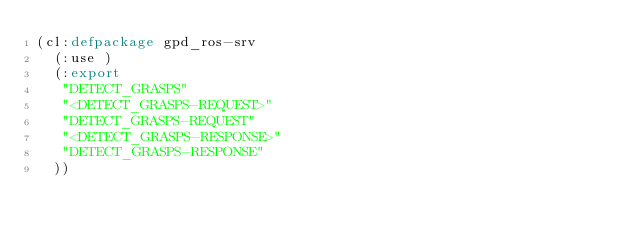Convert code to text. <code><loc_0><loc_0><loc_500><loc_500><_Lisp_>(cl:defpackage gpd_ros-srv
  (:use )
  (:export
   "DETECT_GRASPS"
   "<DETECT_GRASPS-REQUEST>"
   "DETECT_GRASPS-REQUEST"
   "<DETECT_GRASPS-RESPONSE>"
   "DETECT_GRASPS-RESPONSE"
  ))

</code> 